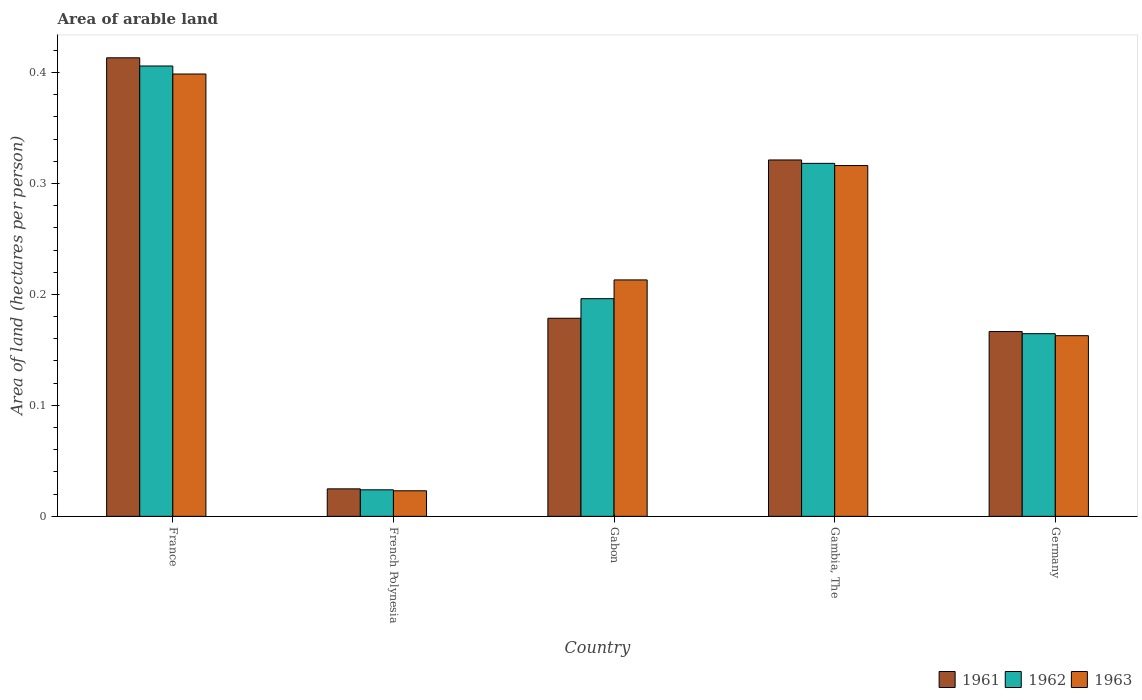How many different coloured bars are there?
Give a very brief answer. 3. Are the number of bars per tick equal to the number of legend labels?
Offer a terse response. Yes. How many bars are there on the 5th tick from the left?
Ensure brevity in your answer.  3. How many bars are there on the 3rd tick from the right?
Ensure brevity in your answer.  3. What is the label of the 4th group of bars from the left?
Offer a very short reply. Gambia, The. In how many cases, is the number of bars for a given country not equal to the number of legend labels?
Ensure brevity in your answer.  0. What is the total arable land in 1963 in Germany?
Ensure brevity in your answer.  0.16. Across all countries, what is the maximum total arable land in 1962?
Make the answer very short. 0.41. Across all countries, what is the minimum total arable land in 1963?
Your answer should be very brief. 0.02. In which country was the total arable land in 1961 maximum?
Your answer should be very brief. France. In which country was the total arable land in 1962 minimum?
Your response must be concise. French Polynesia. What is the total total arable land in 1961 in the graph?
Offer a terse response. 1.1. What is the difference between the total arable land in 1963 in French Polynesia and that in Gabon?
Offer a terse response. -0.19. What is the difference between the total arable land in 1963 in French Polynesia and the total arable land in 1962 in Gambia, The?
Your answer should be compact. -0.3. What is the average total arable land in 1961 per country?
Provide a succinct answer. 0.22. What is the difference between the total arable land of/in 1962 and total arable land of/in 1963 in France?
Ensure brevity in your answer.  0.01. In how many countries, is the total arable land in 1962 greater than 0.32000000000000006 hectares per person?
Provide a succinct answer. 1. What is the ratio of the total arable land in 1963 in French Polynesia to that in Germany?
Offer a terse response. 0.14. Is the total arable land in 1961 in French Polynesia less than that in Gambia, The?
Provide a succinct answer. Yes. Is the difference between the total arable land in 1962 in France and French Polynesia greater than the difference between the total arable land in 1963 in France and French Polynesia?
Your answer should be very brief. Yes. What is the difference between the highest and the second highest total arable land in 1963?
Your response must be concise. 0.19. What is the difference between the highest and the lowest total arable land in 1962?
Your answer should be compact. 0.38. Are all the bars in the graph horizontal?
Give a very brief answer. No. What is the difference between two consecutive major ticks on the Y-axis?
Your answer should be compact. 0.1. Does the graph contain any zero values?
Give a very brief answer. No. How many legend labels are there?
Your answer should be compact. 3. What is the title of the graph?
Make the answer very short. Area of arable land. What is the label or title of the Y-axis?
Ensure brevity in your answer.  Area of land (hectares per person). What is the Area of land (hectares per person) in 1961 in France?
Ensure brevity in your answer.  0.41. What is the Area of land (hectares per person) in 1962 in France?
Your answer should be compact. 0.41. What is the Area of land (hectares per person) in 1963 in France?
Offer a terse response. 0.4. What is the Area of land (hectares per person) of 1961 in French Polynesia?
Your answer should be very brief. 0.02. What is the Area of land (hectares per person) of 1962 in French Polynesia?
Give a very brief answer. 0.02. What is the Area of land (hectares per person) in 1963 in French Polynesia?
Keep it short and to the point. 0.02. What is the Area of land (hectares per person) of 1961 in Gabon?
Provide a succinct answer. 0.18. What is the Area of land (hectares per person) of 1962 in Gabon?
Ensure brevity in your answer.  0.2. What is the Area of land (hectares per person) in 1963 in Gabon?
Keep it short and to the point. 0.21. What is the Area of land (hectares per person) in 1961 in Gambia, The?
Offer a terse response. 0.32. What is the Area of land (hectares per person) in 1962 in Gambia, The?
Ensure brevity in your answer.  0.32. What is the Area of land (hectares per person) in 1963 in Gambia, The?
Give a very brief answer. 0.32. What is the Area of land (hectares per person) of 1961 in Germany?
Ensure brevity in your answer.  0.17. What is the Area of land (hectares per person) of 1962 in Germany?
Keep it short and to the point. 0.16. What is the Area of land (hectares per person) in 1963 in Germany?
Your answer should be very brief. 0.16. Across all countries, what is the maximum Area of land (hectares per person) of 1961?
Offer a terse response. 0.41. Across all countries, what is the maximum Area of land (hectares per person) in 1962?
Offer a very short reply. 0.41. Across all countries, what is the maximum Area of land (hectares per person) of 1963?
Give a very brief answer. 0.4. Across all countries, what is the minimum Area of land (hectares per person) in 1961?
Give a very brief answer. 0.02. Across all countries, what is the minimum Area of land (hectares per person) of 1962?
Your answer should be compact. 0.02. Across all countries, what is the minimum Area of land (hectares per person) of 1963?
Provide a succinct answer. 0.02. What is the total Area of land (hectares per person) in 1961 in the graph?
Provide a short and direct response. 1.1. What is the total Area of land (hectares per person) in 1962 in the graph?
Your answer should be very brief. 1.11. What is the total Area of land (hectares per person) in 1963 in the graph?
Ensure brevity in your answer.  1.11. What is the difference between the Area of land (hectares per person) of 1961 in France and that in French Polynesia?
Your response must be concise. 0.39. What is the difference between the Area of land (hectares per person) in 1962 in France and that in French Polynesia?
Give a very brief answer. 0.38. What is the difference between the Area of land (hectares per person) of 1963 in France and that in French Polynesia?
Your answer should be compact. 0.38. What is the difference between the Area of land (hectares per person) of 1961 in France and that in Gabon?
Give a very brief answer. 0.23. What is the difference between the Area of land (hectares per person) in 1962 in France and that in Gabon?
Your answer should be very brief. 0.21. What is the difference between the Area of land (hectares per person) of 1963 in France and that in Gabon?
Offer a very short reply. 0.19. What is the difference between the Area of land (hectares per person) of 1961 in France and that in Gambia, The?
Your answer should be very brief. 0.09. What is the difference between the Area of land (hectares per person) in 1962 in France and that in Gambia, The?
Provide a succinct answer. 0.09. What is the difference between the Area of land (hectares per person) in 1963 in France and that in Gambia, The?
Provide a succinct answer. 0.08. What is the difference between the Area of land (hectares per person) of 1961 in France and that in Germany?
Offer a very short reply. 0.25. What is the difference between the Area of land (hectares per person) in 1962 in France and that in Germany?
Provide a succinct answer. 0.24. What is the difference between the Area of land (hectares per person) of 1963 in France and that in Germany?
Ensure brevity in your answer.  0.24. What is the difference between the Area of land (hectares per person) of 1961 in French Polynesia and that in Gabon?
Provide a short and direct response. -0.15. What is the difference between the Area of land (hectares per person) of 1962 in French Polynesia and that in Gabon?
Make the answer very short. -0.17. What is the difference between the Area of land (hectares per person) of 1963 in French Polynesia and that in Gabon?
Provide a short and direct response. -0.19. What is the difference between the Area of land (hectares per person) of 1961 in French Polynesia and that in Gambia, The?
Your answer should be compact. -0.3. What is the difference between the Area of land (hectares per person) of 1962 in French Polynesia and that in Gambia, The?
Provide a succinct answer. -0.29. What is the difference between the Area of land (hectares per person) of 1963 in French Polynesia and that in Gambia, The?
Provide a succinct answer. -0.29. What is the difference between the Area of land (hectares per person) in 1961 in French Polynesia and that in Germany?
Keep it short and to the point. -0.14. What is the difference between the Area of land (hectares per person) of 1962 in French Polynesia and that in Germany?
Your answer should be compact. -0.14. What is the difference between the Area of land (hectares per person) of 1963 in French Polynesia and that in Germany?
Your answer should be compact. -0.14. What is the difference between the Area of land (hectares per person) of 1961 in Gabon and that in Gambia, The?
Your answer should be very brief. -0.14. What is the difference between the Area of land (hectares per person) in 1962 in Gabon and that in Gambia, The?
Your response must be concise. -0.12. What is the difference between the Area of land (hectares per person) in 1963 in Gabon and that in Gambia, The?
Your response must be concise. -0.1. What is the difference between the Area of land (hectares per person) of 1961 in Gabon and that in Germany?
Your answer should be compact. 0.01. What is the difference between the Area of land (hectares per person) in 1962 in Gabon and that in Germany?
Your answer should be compact. 0.03. What is the difference between the Area of land (hectares per person) in 1963 in Gabon and that in Germany?
Your answer should be compact. 0.05. What is the difference between the Area of land (hectares per person) in 1961 in Gambia, The and that in Germany?
Ensure brevity in your answer.  0.15. What is the difference between the Area of land (hectares per person) in 1962 in Gambia, The and that in Germany?
Your answer should be compact. 0.15. What is the difference between the Area of land (hectares per person) of 1963 in Gambia, The and that in Germany?
Ensure brevity in your answer.  0.15. What is the difference between the Area of land (hectares per person) of 1961 in France and the Area of land (hectares per person) of 1962 in French Polynesia?
Make the answer very short. 0.39. What is the difference between the Area of land (hectares per person) in 1961 in France and the Area of land (hectares per person) in 1963 in French Polynesia?
Give a very brief answer. 0.39. What is the difference between the Area of land (hectares per person) of 1962 in France and the Area of land (hectares per person) of 1963 in French Polynesia?
Keep it short and to the point. 0.38. What is the difference between the Area of land (hectares per person) of 1961 in France and the Area of land (hectares per person) of 1962 in Gabon?
Your response must be concise. 0.22. What is the difference between the Area of land (hectares per person) of 1961 in France and the Area of land (hectares per person) of 1963 in Gabon?
Offer a very short reply. 0.2. What is the difference between the Area of land (hectares per person) of 1962 in France and the Area of land (hectares per person) of 1963 in Gabon?
Provide a succinct answer. 0.19. What is the difference between the Area of land (hectares per person) of 1961 in France and the Area of land (hectares per person) of 1962 in Gambia, The?
Offer a terse response. 0.1. What is the difference between the Area of land (hectares per person) of 1961 in France and the Area of land (hectares per person) of 1963 in Gambia, The?
Ensure brevity in your answer.  0.1. What is the difference between the Area of land (hectares per person) of 1962 in France and the Area of land (hectares per person) of 1963 in Gambia, The?
Your response must be concise. 0.09. What is the difference between the Area of land (hectares per person) in 1961 in France and the Area of land (hectares per person) in 1962 in Germany?
Offer a terse response. 0.25. What is the difference between the Area of land (hectares per person) in 1961 in France and the Area of land (hectares per person) in 1963 in Germany?
Your answer should be compact. 0.25. What is the difference between the Area of land (hectares per person) of 1962 in France and the Area of land (hectares per person) of 1963 in Germany?
Ensure brevity in your answer.  0.24. What is the difference between the Area of land (hectares per person) in 1961 in French Polynesia and the Area of land (hectares per person) in 1962 in Gabon?
Your answer should be compact. -0.17. What is the difference between the Area of land (hectares per person) in 1961 in French Polynesia and the Area of land (hectares per person) in 1963 in Gabon?
Your response must be concise. -0.19. What is the difference between the Area of land (hectares per person) of 1962 in French Polynesia and the Area of land (hectares per person) of 1963 in Gabon?
Give a very brief answer. -0.19. What is the difference between the Area of land (hectares per person) in 1961 in French Polynesia and the Area of land (hectares per person) in 1962 in Gambia, The?
Provide a short and direct response. -0.29. What is the difference between the Area of land (hectares per person) of 1961 in French Polynesia and the Area of land (hectares per person) of 1963 in Gambia, The?
Provide a succinct answer. -0.29. What is the difference between the Area of land (hectares per person) in 1962 in French Polynesia and the Area of land (hectares per person) in 1963 in Gambia, The?
Make the answer very short. -0.29. What is the difference between the Area of land (hectares per person) of 1961 in French Polynesia and the Area of land (hectares per person) of 1962 in Germany?
Your answer should be very brief. -0.14. What is the difference between the Area of land (hectares per person) in 1961 in French Polynesia and the Area of land (hectares per person) in 1963 in Germany?
Provide a succinct answer. -0.14. What is the difference between the Area of land (hectares per person) of 1962 in French Polynesia and the Area of land (hectares per person) of 1963 in Germany?
Make the answer very short. -0.14. What is the difference between the Area of land (hectares per person) of 1961 in Gabon and the Area of land (hectares per person) of 1962 in Gambia, The?
Provide a short and direct response. -0.14. What is the difference between the Area of land (hectares per person) of 1961 in Gabon and the Area of land (hectares per person) of 1963 in Gambia, The?
Offer a terse response. -0.14. What is the difference between the Area of land (hectares per person) in 1962 in Gabon and the Area of land (hectares per person) in 1963 in Gambia, The?
Provide a succinct answer. -0.12. What is the difference between the Area of land (hectares per person) of 1961 in Gabon and the Area of land (hectares per person) of 1962 in Germany?
Ensure brevity in your answer.  0.01. What is the difference between the Area of land (hectares per person) of 1961 in Gabon and the Area of land (hectares per person) of 1963 in Germany?
Provide a short and direct response. 0.02. What is the difference between the Area of land (hectares per person) in 1962 in Gabon and the Area of land (hectares per person) in 1963 in Germany?
Provide a succinct answer. 0.03. What is the difference between the Area of land (hectares per person) of 1961 in Gambia, The and the Area of land (hectares per person) of 1962 in Germany?
Provide a short and direct response. 0.16. What is the difference between the Area of land (hectares per person) in 1961 in Gambia, The and the Area of land (hectares per person) in 1963 in Germany?
Give a very brief answer. 0.16. What is the difference between the Area of land (hectares per person) in 1962 in Gambia, The and the Area of land (hectares per person) in 1963 in Germany?
Keep it short and to the point. 0.16. What is the average Area of land (hectares per person) of 1961 per country?
Provide a succinct answer. 0.22. What is the average Area of land (hectares per person) of 1962 per country?
Offer a terse response. 0.22. What is the average Area of land (hectares per person) in 1963 per country?
Keep it short and to the point. 0.22. What is the difference between the Area of land (hectares per person) of 1961 and Area of land (hectares per person) of 1962 in France?
Keep it short and to the point. 0.01. What is the difference between the Area of land (hectares per person) in 1961 and Area of land (hectares per person) in 1963 in France?
Offer a very short reply. 0.01. What is the difference between the Area of land (hectares per person) of 1962 and Area of land (hectares per person) of 1963 in France?
Provide a short and direct response. 0.01. What is the difference between the Area of land (hectares per person) in 1961 and Area of land (hectares per person) in 1962 in French Polynesia?
Ensure brevity in your answer.  0. What is the difference between the Area of land (hectares per person) in 1961 and Area of land (hectares per person) in 1963 in French Polynesia?
Ensure brevity in your answer.  0. What is the difference between the Area of land (hectares per person) of 1962 and Area of land (hectares per person) of 1963 in French Polynesia?
Offer a very short reply. 0. What is the difference between the Area of land (hectares per person) of 1961 and Area of land (hectares per person) of 1962 in Gabon?
Ensure brevity in your answer.  -0.02. What is the difference between the Area of land (hectares per person) in 1961 and Area of land (hectares per person) in 1963 in Gabon?
Your response must be concise. -0.03. What is the difference between the Area of land (hectares per person) of 1962 and Area of land (hectares per person) of 1963 in Gabon?
Provide a short and direct response. -0.02. What is the difference between the Area of land (hectares per person) of 1961 and Area of land (hectares per person) of 1962 in Gambia, The?
Make the answer very short. 0. What is the difference between the Area of land (hectares per person) of 1961 and Area of land (hectares per person) of 1963 in Gambia, The?
Your answer should be very brief. 0.01. What is the difference between the Area of land (hectares per person) of 1962 and Area of land (hectares per person) of 1963 in Gambia, The?
Make the answer very short. 0. What is the difference between the Area of land (hectares per person) in 1961 and Area of land (hectares per person) in 1962 in Germany?
Give a very brief answer. 0. What is the difference between the Area of land (hectares per person) in 1961 and Area of land (hectares per person) in 1963 in Germany?
Provide a succinct answer. 0. What is the difference between the Area of land (hectares per person) of 1962 and Area of land (hectares per person) of 1963 in Germany?
Offer a terse response. 0. What is the ratio of the Area of land (hectares per person) of 1961 in France to that in French Polynesia?
Your answer should be compact. 16.68. What is the ratio of the Area of land (hectares per person) of 1962 in France to that in French Polynesia?
Keep it short and to the point. 16.98. What is the ratio of the Area of land (hectares per person) of 1963 in France to that in French Polynesia?
Ensure brevity in your answer.  17.31. What is the ratio of the Area of land (hectares per person) in 1961 in France to that in Gabon?
Your response must be concise. 2.31. What is the ratio of the Area of land (hectares per person) in 1962 in France to that in Gabon?
Make the answer very short. 2.07. What is the ratio of the Area of land (hectares per person) in 1963 in France to that in Gabon?
Provide a succinct answer. 1.87. What is the ratio of the Area of land (hectares per person) in 1961 in France to that in Gambia, The?
Your answer should be very brief. 1.29. What is the ratio of the Area of land (hectares per person) of 1962 in France to that in Gambia, The?
Give a very brief answer. 1.28. What is the ratio of the Area of land (hectares per person) of 1963 in France to that in Gambia, The?
Your answer should be compact. 1.26. What is the ratio of the Area of land (hectares per person) of 1961 in France to that in Germany?
Your answer should be very brief. 2.48. What is the ratio of the Area of land (hectares per person) in 1962 in France to that in Germany?
Your response must be concise. 2.47. What is the ratio of the Area of land (hectares per person) of 1963 in France to that in Germany?
Provide a succinct answer. 2.45. What is the ratio of the Area of land (hectares per person) in 1961 in French Polynesia to that in Gabon?
Offer a very short reply. 0.14. What is the ratio of the Area of land (hectares per person) in 1962 in French Polynesia to that in Gabon?
Offer a very short reply. 0.12. What is the ratio of the Area of land (hectares per person) in 1963 in French Polynesia to that in Gabon?
Offer a terse response. 0.11. What is the ratio of the Area of land (hectares per person) of 1961 in French Polynesia to that in Gambia, The?
Give a very brief answer. 0.08. What is the ratio of the Area of land (hectares per person) in 1962 in French Polynesia to that in Gambia, The?
Keep it short and to the point. 0.08. What is the ratio of the Area of land (hectares per person) of 1963 in French Polynesia to that in Gambia, The?
Provide a short and direct response. 0.07. What is the ratio of the Area of land (hectares per person) of 1961 in French Polynesia to that in Germany?
Keep it short and to the point. 0.15. What is the ratio of the Area of land (hectares per person) of 1962 in French Polynesia to that in Germany?
Your answer should be compact. 0.15. What is the ratio of the Area of land (hectares per person) of 1963 in French Polynesia to that in Germany?
Provide a succinct answer. 0.14. What is the ratio of the Area of land (hectares per person) of 1961 in Gabon to that in Gambia, The?
Your response must be concise. 0.56. What is the ratio of the Area of land (hectares per person) of 1962 in Gabon to that in Gambia, The?
Give a very brief answer. 0.62. What is the ratio of the Area of land (hectares per person) in 1963 in Gabon to that in Gambia, The?
Your response must be concise. 0.67. What is the ratio of the Area of land (hectares per person) in 1961 in Gabon to that in Germany?
Keep it short and to the point. 1.07. What is the ratio of the Area of land (hectares per person) in 1962 in Gabon to that in Germany?
Your answer should be very brief. 1.19. What is the ratio of the Area of land (hectares per person) of 1963 in Gabon to that in Germany?
Keep it short and to the point. 1.31. What is the ratio of the Area of land (hectares per person) of 1961 in Gambia, The to that in Germany?
Your answer should be very brief. 1.93. What is the ratio of the Area of land (hectares per person) in 1962 in Gambia, The to that in Germany?
Keep it short and to the point. 1.93. What is the ratio of the Area of land (hectares per person) of 1963 in Gambia, The to that in Germany?
Provide a succinct answer. 1.94. What is the difference between the highest and the second highest Area of land (hectares per person) in 1961?
Your answer should be compact. 0.09. What is the difference between the highest and the second highest Area of land (hectares per person) of 1962?
Make the answer very short. 0.09. What is the difference between the highest and the second highest Area of land (hectares per person) in 1963?
Make the answer very short. 0.08. What is the difference between the highest and the lowest Area of land (hectares per person) in 1961?
Ensure brevity in your answer.  0.39. What is the difference between the highest and the lowest Area of land (hectares per person) in 1962?
Make the answer very short. 0.38. What is the difference between the highest and the lowest Area of land (hectares per person) of 1963?
Your answer should be very brief. 0.38. 